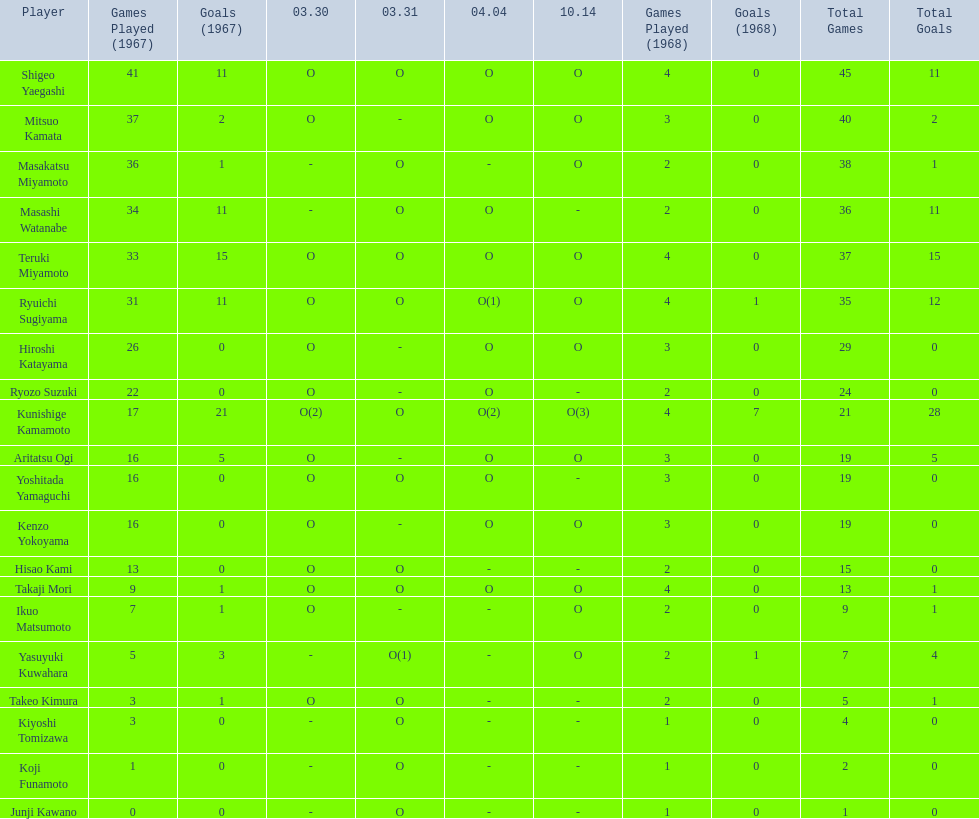Who were the players in the 1968 japanese football? Shigeo Yaegashi, Mitsuo Kamata, Masakatsu Miyamoto, Masashi Watanabe, Teruki Miyamoto, Ryuichi Sugiyama, Hiroshi Katayama, Ryozo Suzuki, Kunishige Kamamoto, Aritatsu Ogi, Yoshitada Yamaguchi, Kenzo Yokoyama, Hisao Kami, Takaji Mori, Ikuo Matsumoto, Yasuyuki Kuwahara, Takeo Kimura, Kiyoshi Tomizawa, Koji Funamoto, Junji Kawano. How many points total did takaji mori have? 13(1). How many points total did junju kawano? 1(0). Who had more points? Takaji Mori. 